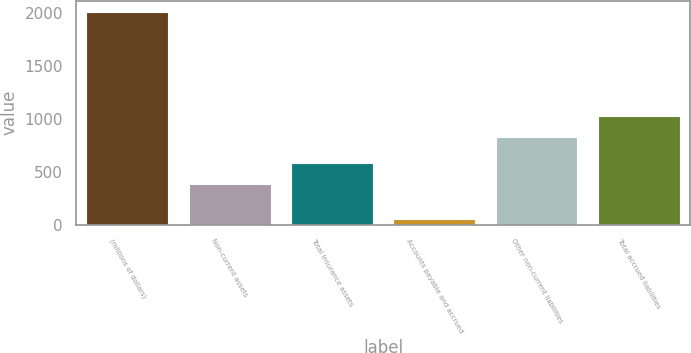Convert chart to OTSL. <chart><loc_0><loc_0><loc_500><loc_500><bar_chart><fcel>(millions of dollars)<fcel>Non-current assets<fcel>Total insurance assets<fcel>Accounts payable and accrued<fcel>Other non-current liabilities<fcel>Total accrued liabilities<nl><fcel>2016<fcel>386.4<fcel>582.83<fcel>51.7<fcel>827.6<fcel>1024.03<nl></chart> 